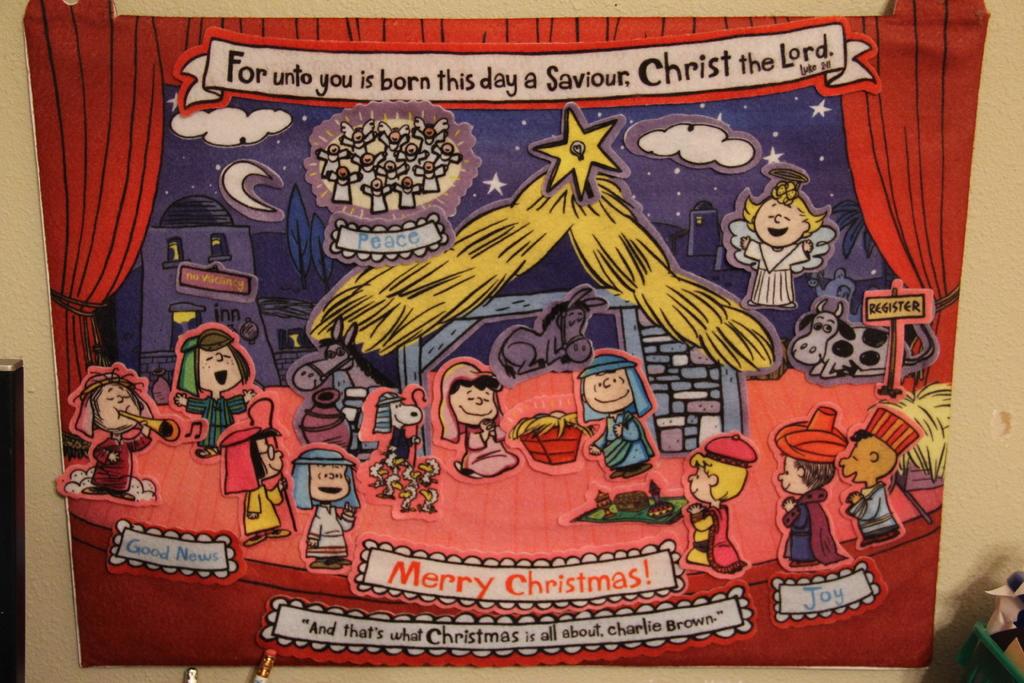Who was born on this day?
Your answer should be very brief. Christ the lord. What are the words in red?
Give a very brief answer. Merry christmas!. 